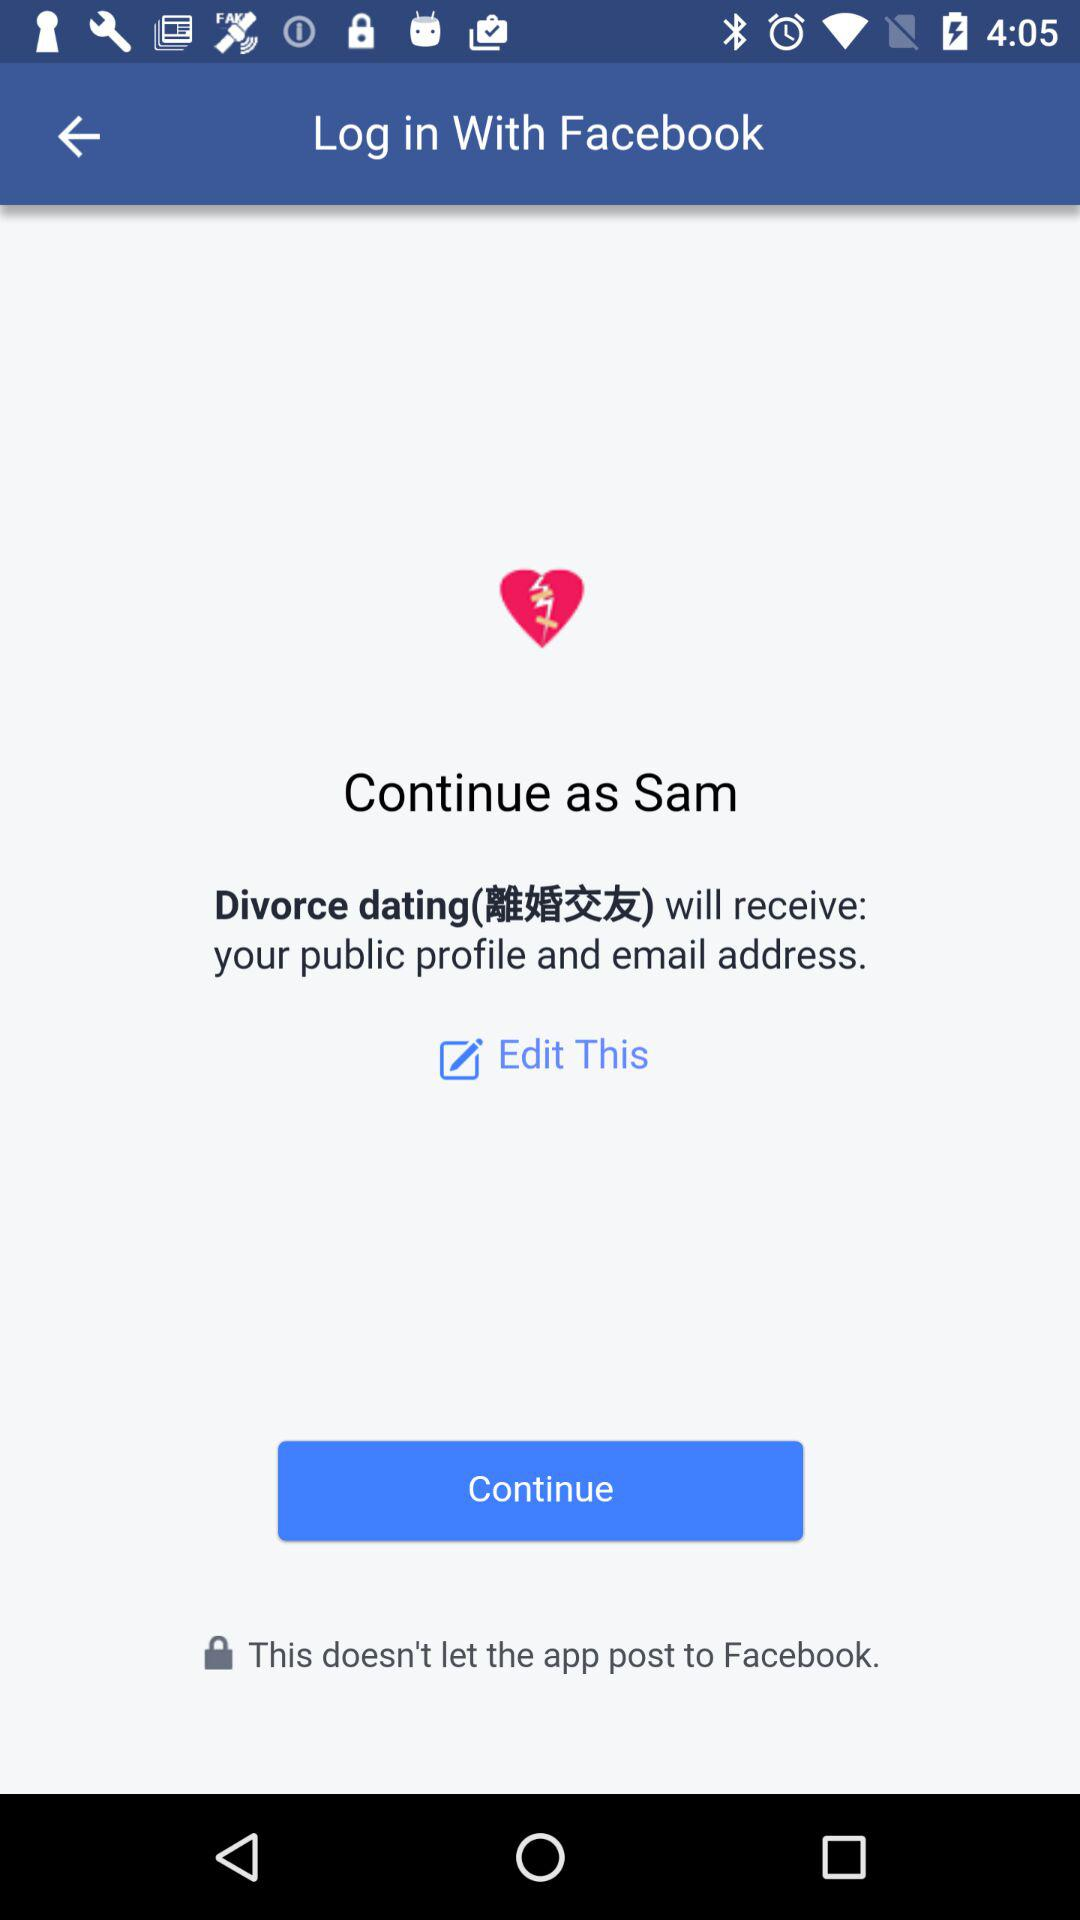What is the application name? The application name is "Facebook" and "Divorce dating". 